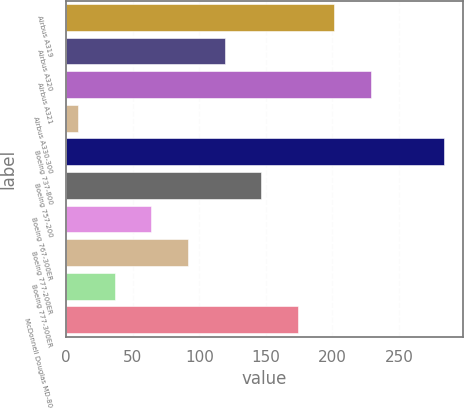Convert chart. <chart><loc_0><loc_0><loc_500><loc_500><bar_chart><fcel>Airbus A319<fcel>Airbus A320<fcel>Airbus A321<fcel>Airbus A330-300<fcel>Boeing 737-800<fcel>Boeing 757-200<fcel>Boeing 767-300ER<fcel>Boeing 777-200ER<fcel>Boeing 777-300ER<fcel>McDonnell Douglas MD-80<nl><fcel>201.5<fcel>119<fcel>229<fcel>9<fcel>284<fcel>146.5<fcel>64<fcel>91.5<fcel>36.5<fcel>174<nl></chart> 